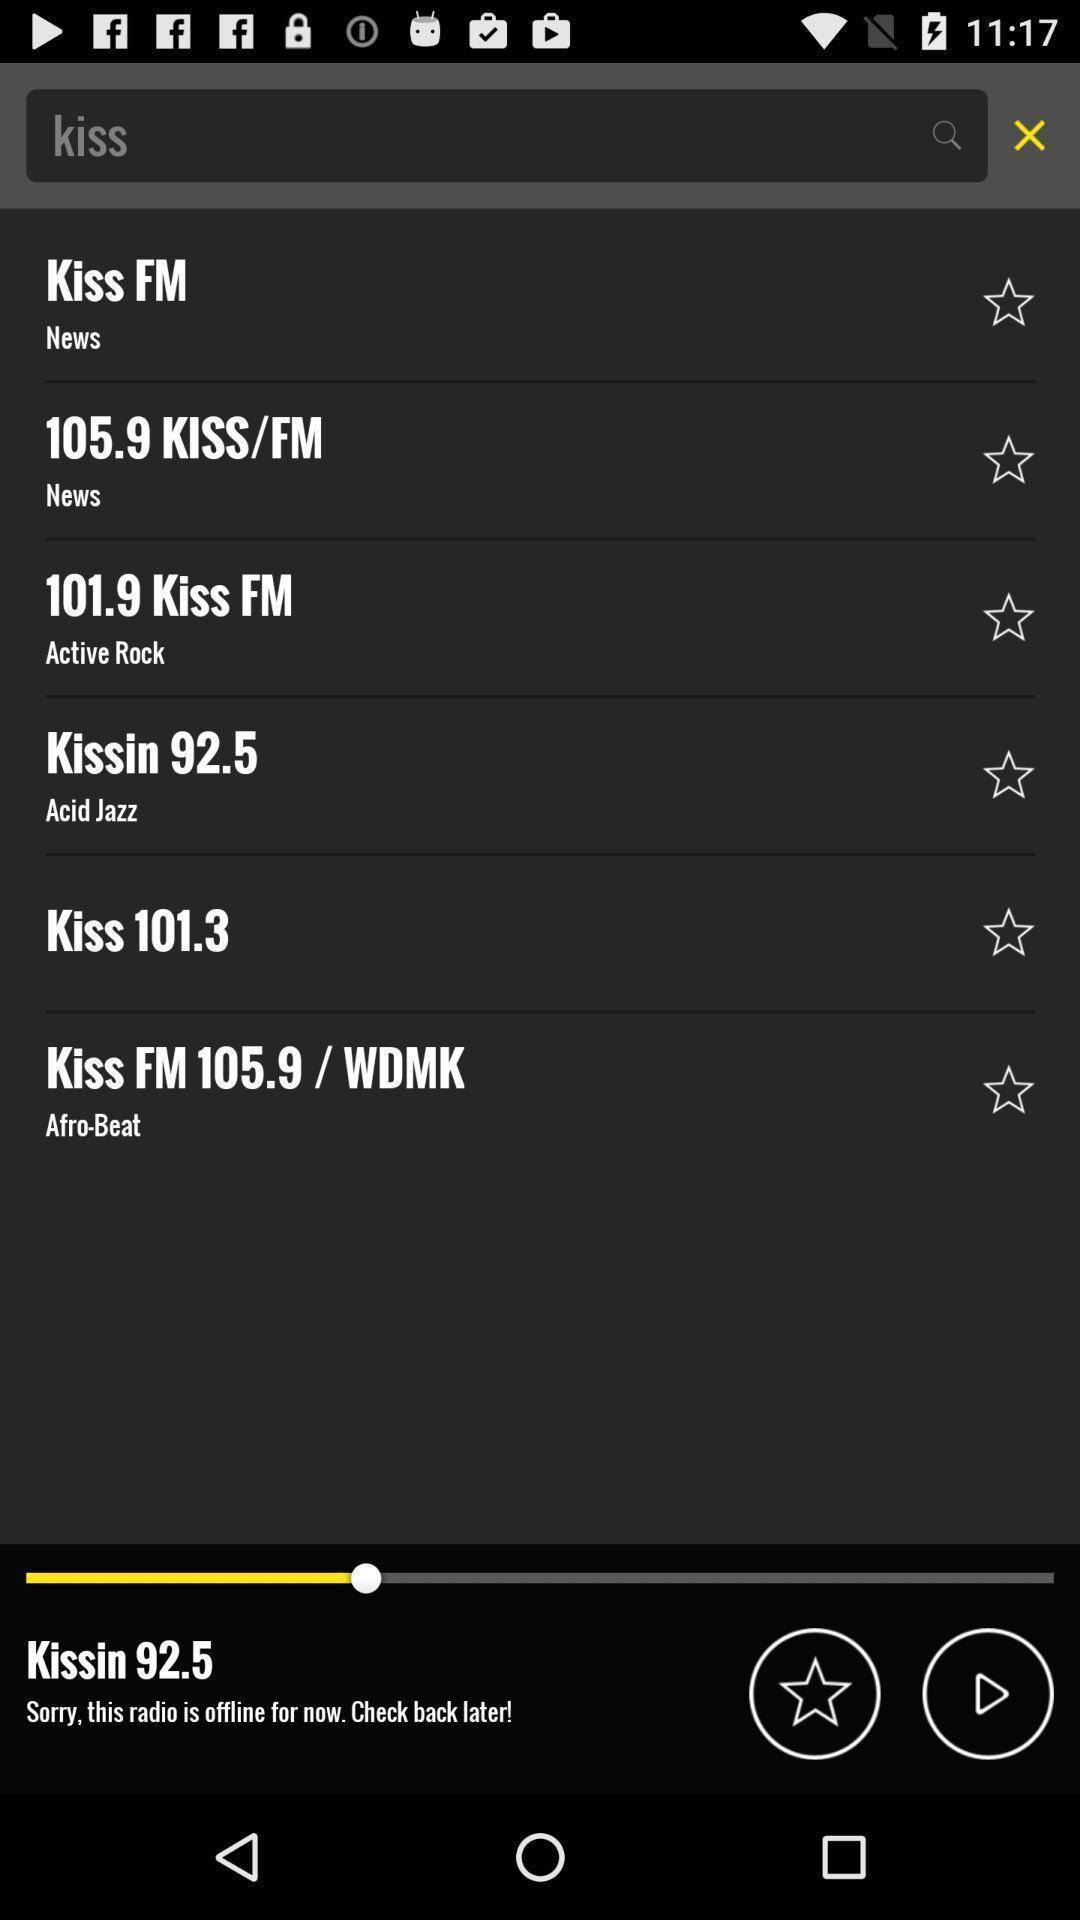Tell me about the visual elements in this screen capture. Search bar with other options in an radio application. 